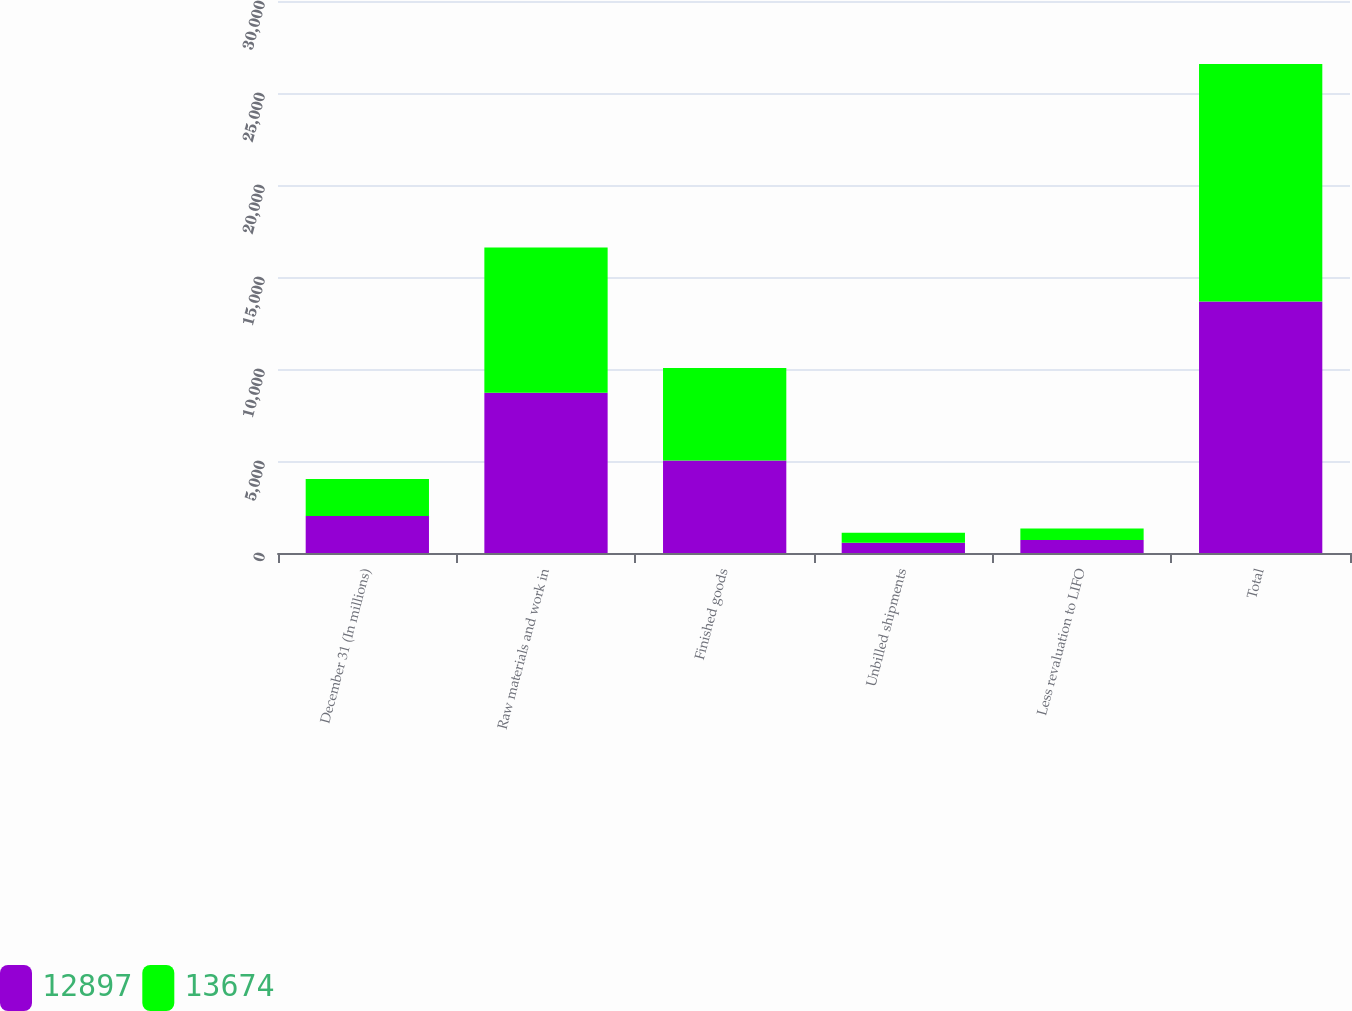Convert chart to OTSL. <chart><loc_0><loc_0><loc_500><loc_500><stacked_bar_chart><ecel><fcel>December 31 (In millions)<fcel>Raw materials and work in<fcel>Finished goods<fcel>Unbilled shipments<fcel>Less revaluation to LIFO<fcel>Total<nl><fcel>12897<fcel>2008<fcel>8710<fcel>5032<fcel>561<fcel>706<fcel>13674<nl><fcel>13674<fcel>2007<fcel>7893<fcel>5025<fcel>539<fcel>623<fcel>12897<nl></chart> 